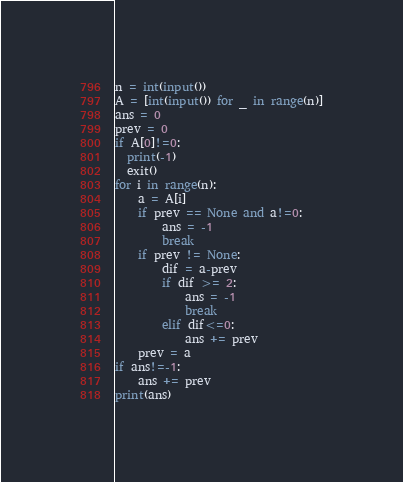<code> <loc_0><loc_0><loc_500><loc_500><_Python_>n = int(input())
A = [int(input()) for _ in range(n)]
ans = 0
prev = 0
if A[0]!=0:
  print(-1)
  exit()
for i in range(n):
    a = A[i]
    if prev == None and a!=0:
        ans = -1
        break
    if prev != None:
        dif = a-prev
        if dif >= 2:
            ans = -1
            break
        elif dif<=0:
            ans += prev
    prev = a
if ans!=-1:
    ans += prev
print(ans)</code> 